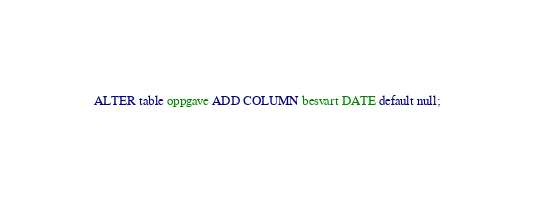Convert code to text. <code><loc_0><loc_0><loc_500><loc_500><_SQL_>ALTER table oppgave ADD COLUMN besvart DATE default null;
</code> 